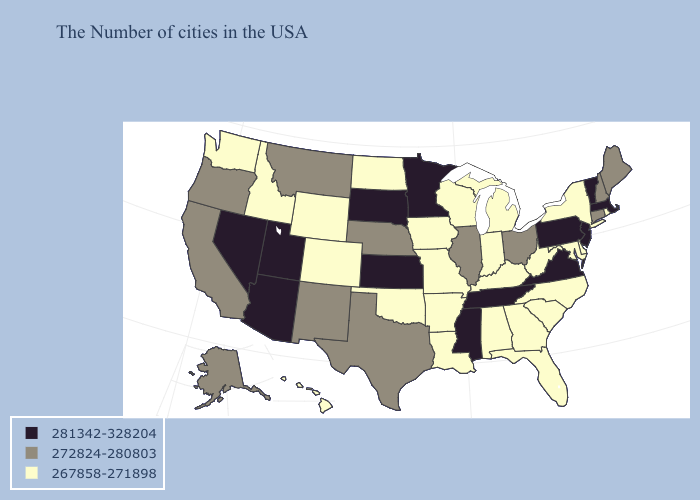Does Alabama have the lowest value in the South?
Short answer required. Yes. What is the highest value in states that border New Mexico?
Concise answer only. 281342-328204. Does New Mexico have a lower value than Delaware?
Concise answer only. No. Name the states that have a value in the range 281342-328204?
Answer briefly. Massachusetts, Vermont, New Jersey, Pennsylvania, Virginia, Tennessee, Mississippi, Minnesota, Kansas, South Dakota, Utah, Arizona, Nevada. How many symbols are there in the legend?
Concise answer only. 3. What is the lowest value in states that border Arkansas?
Be succinct. 267858-271898. What is the value of Arizona?
Short answer required. 281342-328204. Does Wisconsin have the same value as New Hampshire?
Give a very brief answer. No. Does Ohio have a lower value than Virginia?
Keep it brief. Yes. Is the legend a continuous bar?
Be succinct. No. Does Illinois have the same value as Maryland?
Quick response, please. No. Which states have the lowest value in the West?
Give a very brief answer. Wyoming, Colorado, Idaho, Washington, Hawaii. What is the lowest value in the USA?
Keep it brief. 267858-271898. What is the value of Nebraska?
Concise answer only. 272824-280803. What is the value of Wisconsin?
Quick response, please. 267858-271898. 